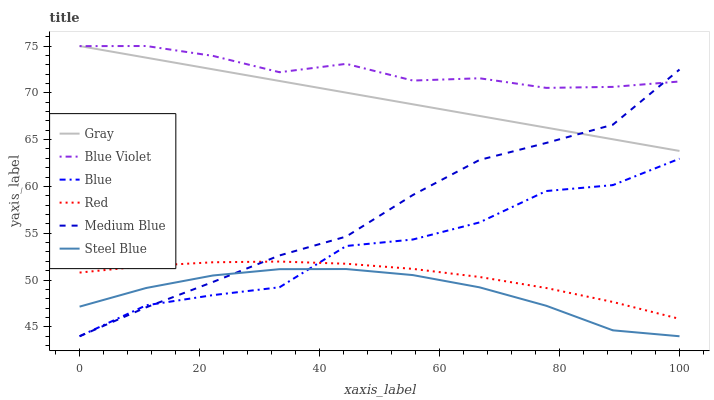Does Gray have the minimum area under the curve?
Answer yes or no. No. Does Gray have the maximum area under the curve?
Answer yes or no. No. Is Medium Blue the smoothest?
Answer yes or no. No. Is Medium Blue the roughest?
Answer yes or no. No. Does Gray have the lowest value?
Answer yes or no. No. Does Medium Blue have the highest value?
Answer yes or no. No. Is Red less than Blue Violet?
Answer yes or no. Yes. Is Gray greater than Steel Blue?
Answer yes or no. Yes. Does Red intersect Blue Violet?
Answer yes or no. No. 